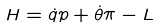<formula> <loc_0><loc_0><loc_500><loc_500>H = \dot { q } p + \dot { \theta } \pi - L</formula> 